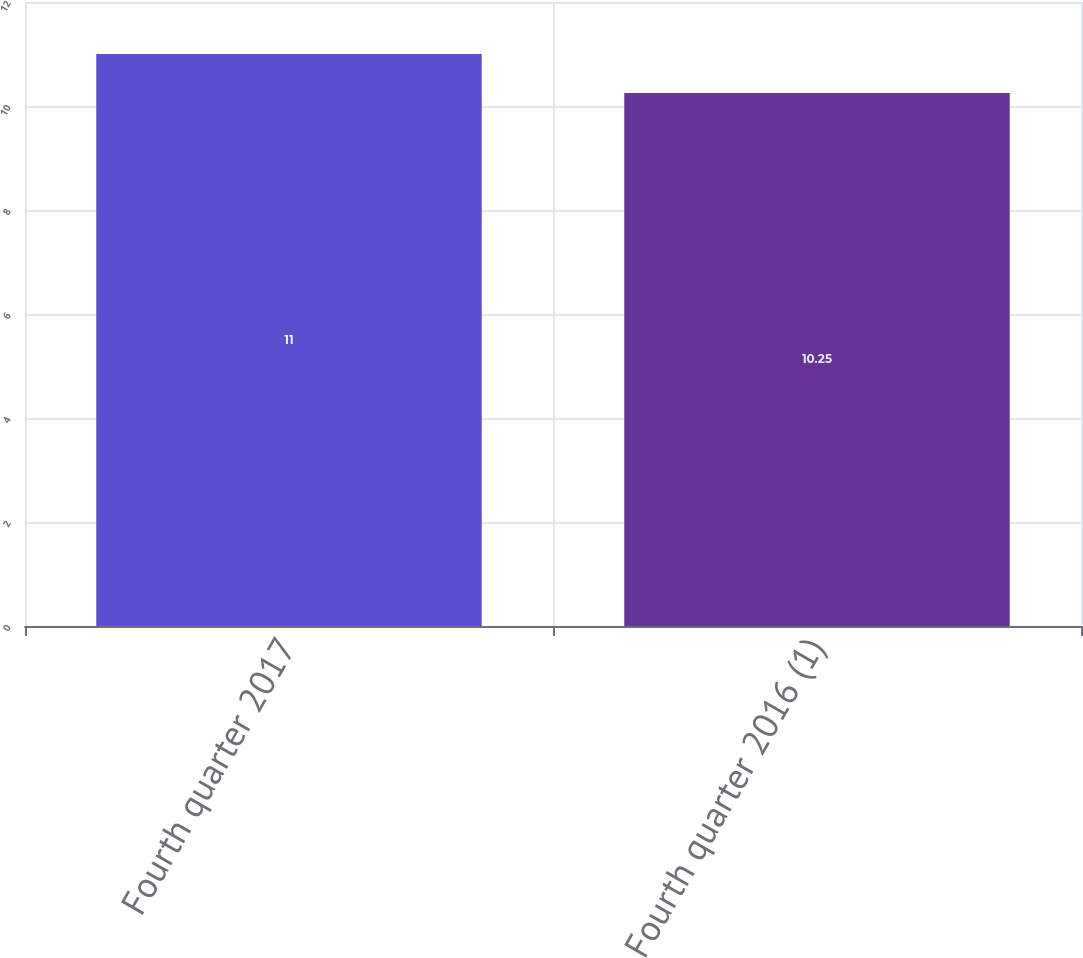<chart> <loc_0><loc_0><loc_500><loc_500><bar_chart><fcel>Fourth quarter 2017<fcel>Fourth quarter 2016 (1)<nl><fcel>11<fcel>10.25<nl></chart> 